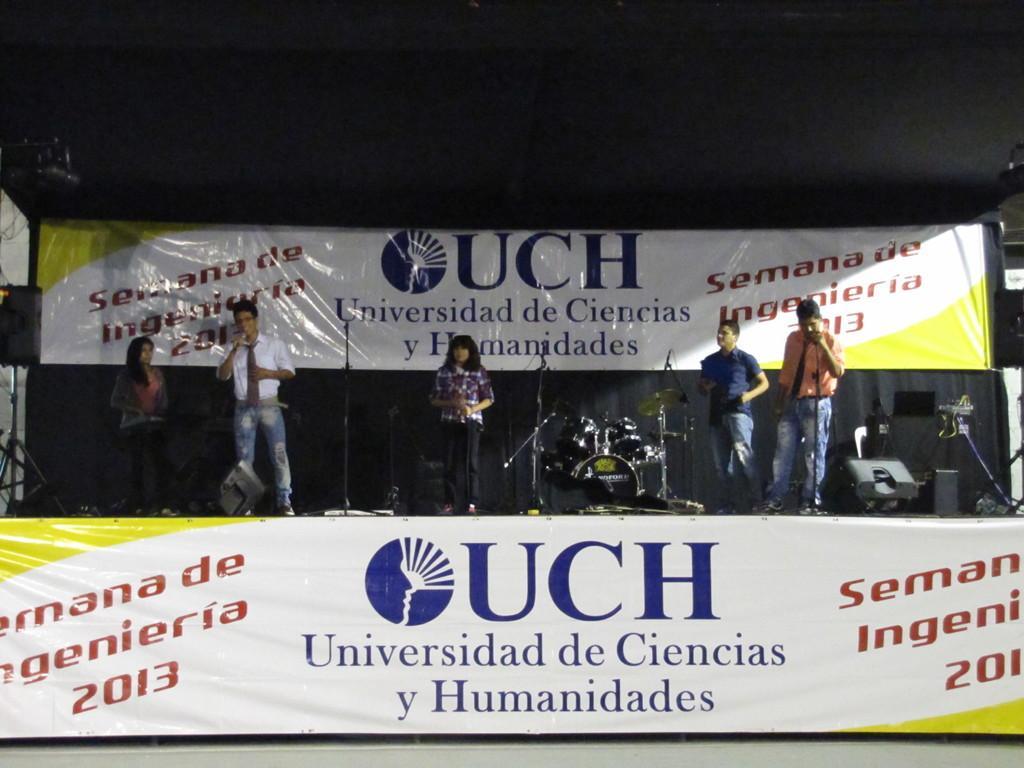Describe this image in one or two sentences. In this image, we can see the stage with some objects like musical instruments, microphones. We can also see a stand. There are a few people. We can also see some banners with images and text. We can also see the dark background. 